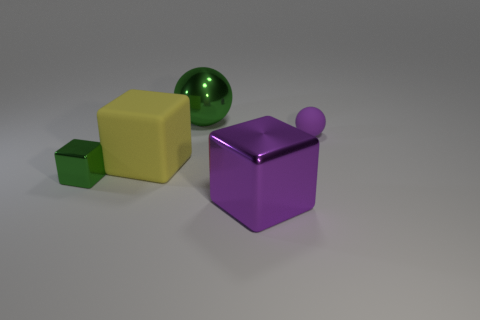What is the shape of the small thing that is the same color as the large shiny cube?
Offer a very short reply. Sphere. Is there a large thing that has the same color as the big matte cube?
Your answer should be compact. No. Does the small object that is in front of the small matte ball have the same shape as the large matte thing to the left of the purple metallic block?
Offer a terse response. Yes. What size is the matte thing that is the same color as the big metal cube?
Keep it short and to the point. Small. How many other objects are the same size as the purple rubber sphere?
Make the answer very short. 1. There is a large rubber block; does it have the same color as the shiny thing on the left side of the large green object?
Offer a terse response. No. Is the number of tiny purple balls on the left side of the purple matte thing less than the number of yellow blocks that are right of the large green shiny object?
Provide a succinct answer. No. There is a shiny thing that is both in front of the big yellow rubber object and right of the tiny green thing; what is its color?
Offer a terse response. Purple. Does the shiny sphere have the same size as the matte object that is right of the big purple cube?
Ensure brevity in your answer.  No. What shape is the small thing that is in front of the purple rubber object?
Provide a short and direct response. Cube. 